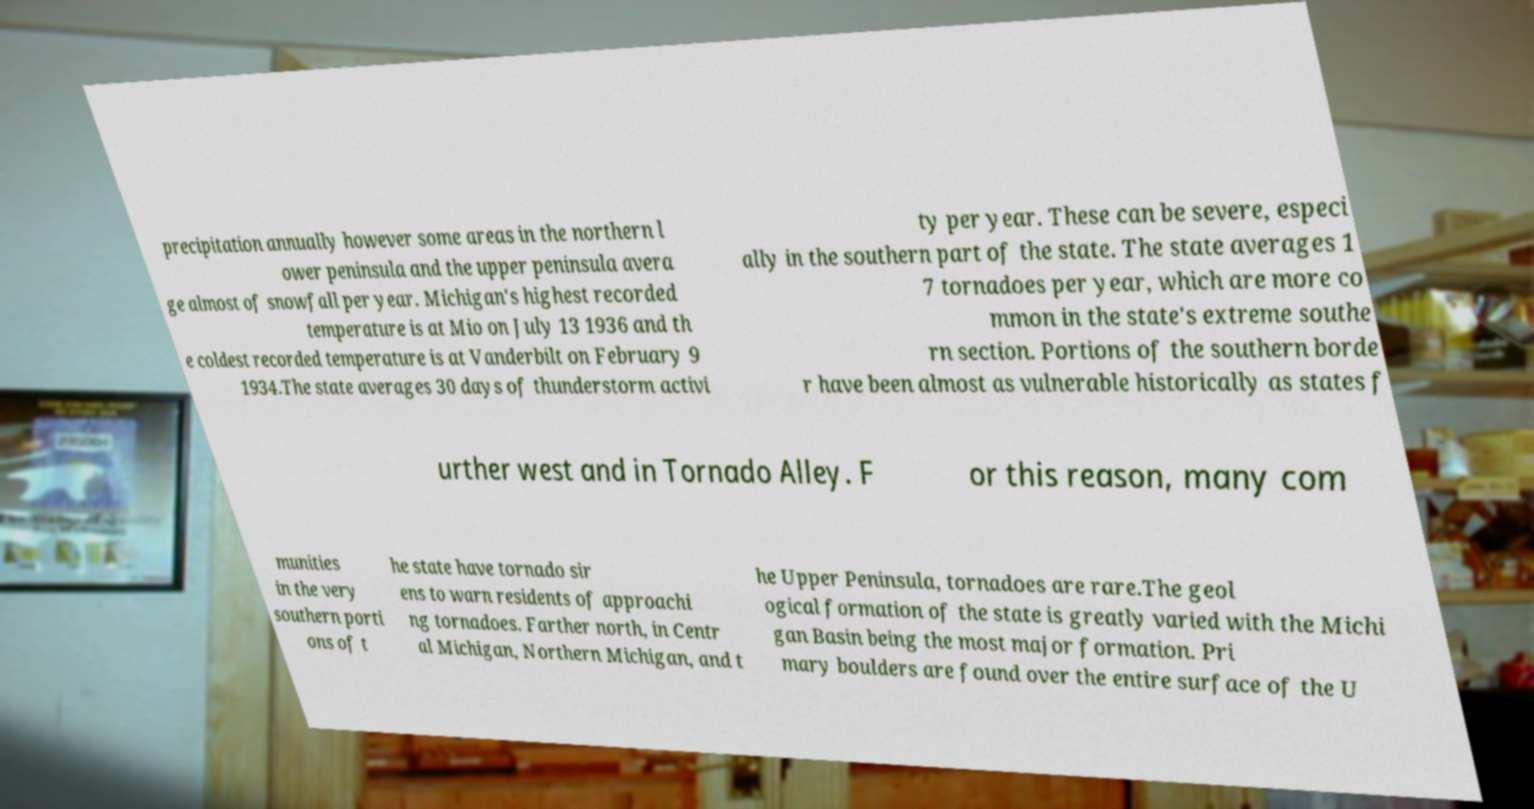Could you extract and type out the text from this image? precipitation annually however some areas in the northern l ower peninsula and the upper peninsula avera ge almost of snowfall per year. Michigan's highest recorded temperature is at Mio on July 13 1936 and th e coldest recorded temperature is at Vanderbilt on February 9 1934.The state averages 30 days of thunderstorm activi ty per year. These can be severe, especi ally in the southern part of the state. The state averages 1 7 tornadoes per year, which are more co mmon in the state's extreme southe rn section. Portions of the southern borde r have been almost as vulnerable historically as states f urther west and in Tornado Alley. F or this reason, many com munities in the very southern porti ons of t he state have tornado sir ens to warn residents of approachi ng tornadoes. Farther north, in Centr al Michigan, Northern Michigan, and t he Upper Peninsula, tornadoes are rare.The geol ogical formation of the state is greatly varied with the Michi gan Basin being the most major formation. Pri mary boulders are found over the entire surface of the U 